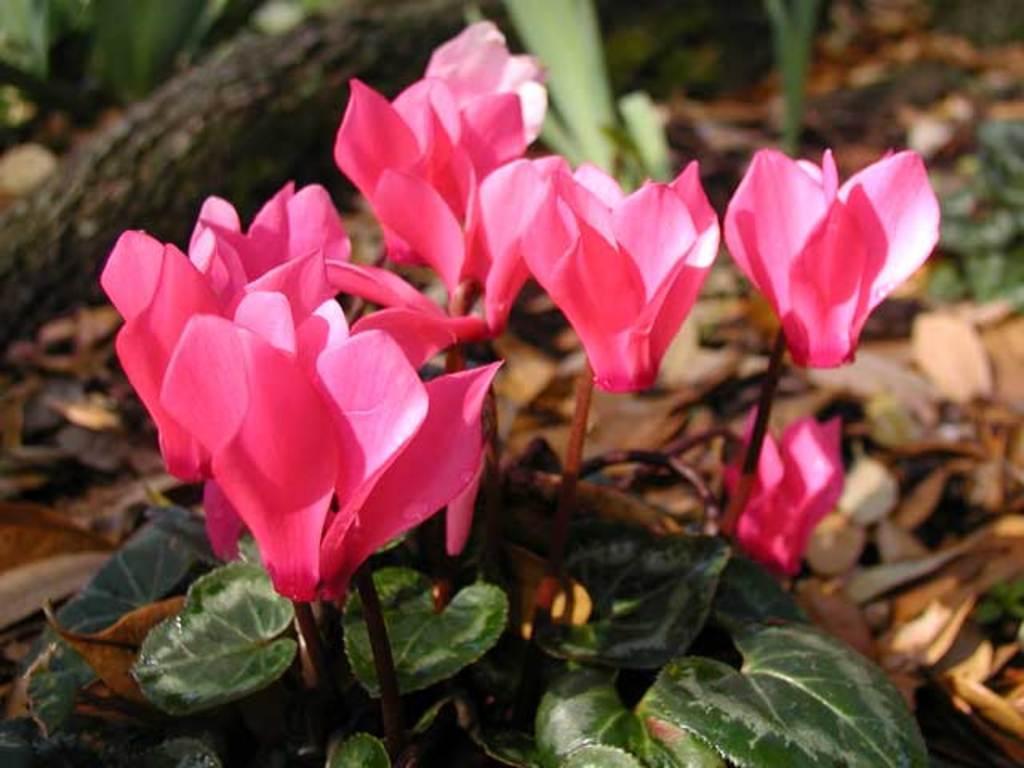Could you give a brief overview of what you see in this image? These are the beautiful flowers in pink color, at the down side there are leaves in green color. 